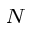<formula> <loc_0><loc_0><loc_500><loc_500>_ { N }</formula> 